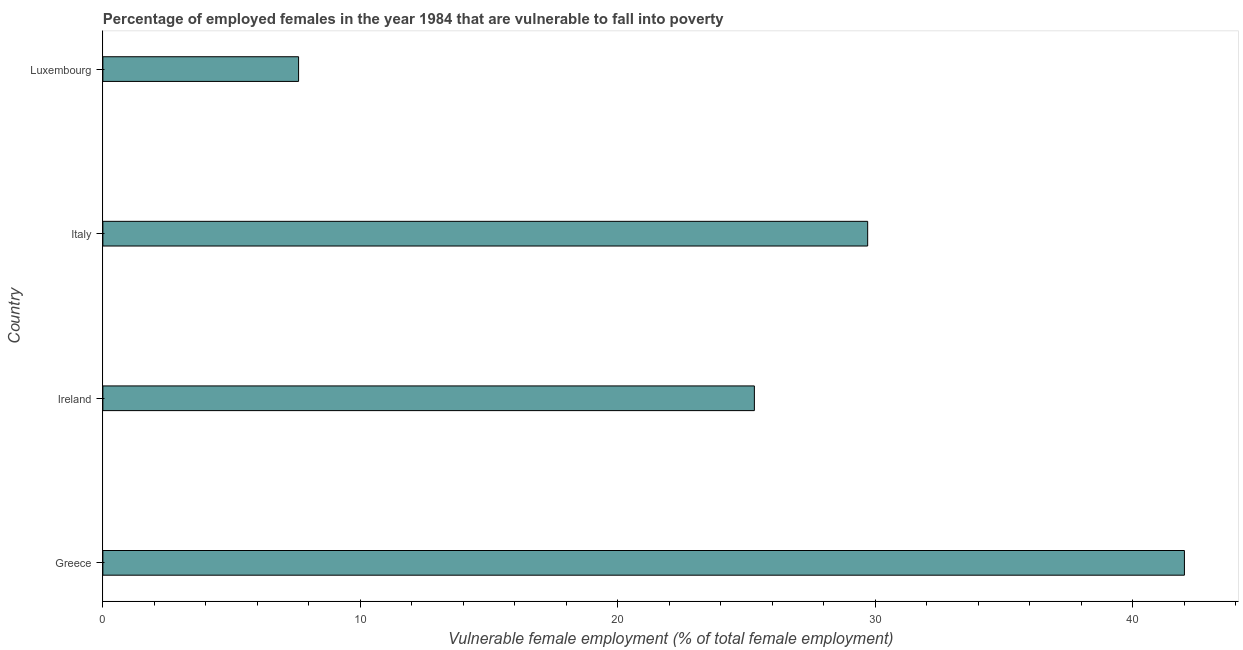Does the graph contain any zero values?
Make the answer very short. No. What is the title of the graph?
Your response must be concise. Percentage of employed females in the year 1984 that are vulnerable to fall into poverty. What is the label or title of the X-axis?
Your response must be concise. Vulnerable female employment (% of total female employment). What is the percentage of employed females who are vulnerable to fall into poverty in Luxembourg?
Your answer should be compact. 7.6. Across all countries, what is the minimum percentage of employed females who are vulnerable to fall into poverty?
Offer a very short reply. 7.6. In which country was the percentage of employed females who are vulnerable to fall into poverty minimum?
Your response must be concise. Luxembourg. What is the sum of the percentage of employed females who are vulnerable to fall into poverty?
Offer a terse response. 104.6. What is the average percentage of employed females who are vulnerable to fall into poverty per country?
Your answer should be very brief. 26.15. What is the ratio of the percentage of employed females who are vulnerable to fall into poverty in Greece to that in Luxembourg?
Offer a very short reply. 5.53. What is the difference between the highest and the lowest percentage of employed females who are vulnerable to fall into poverty?
Keep it short and to the point. 34.4. How many countries are there in the graph?
Provide a short and direct response. 4. Are the values on the major ticks of X-axis written in scientific E-notation?
Ensure brevity in your answer.  No. What is the Vulnerable female employment (% of total female employment) of Greece?
Keep it short and to the point. 42. What is the Vulnerable female employment (% of total female employment) in Ireland?
Provide a succinct answer. 25.3. What is the Vulnerable female employment (% of total female employment) in Italy?
Your answer should be compact. 29.7. What is the Vulnerable female employment (% of total female employment) in Luxembourg?
Offer a terse response. 7.6. What is the difference between the Vulnerable female employment (% of total female employment) in Greece and Ireland?
Ensure brevity in your answer.  16.7. What is the difference between the Vulnerable female employment (% of total female employment) in Greece and Luxembourg?
Your answer should be very brief. 34.4. What is the difference between the Vulnerable female employment (% of total female employment) in Italy and Luxembourg?
Your answer should be compact. 22.1. What is the ratio of the Vulnerable female employment (% of total female employment) in Greece to that in Ireland?
Your response must be concise. 1.66. What is the ratio of the Vulnerable female employment (% of total female employment) in Greece to that in Italy?
Give a very brief answer. 1.41. What is the ratio of the Vulnerable female employment (% of total female employment) in Greece to that in Luxembourg?
Offer a very short reply. 5.53. What is the ratio of the Vulnerable female employment (% of total female employment) in Ireland to that in Italy?
Keep it short and to the point. 0.85. What is the ratio of the Vulnerable female employment (% of total female employment) in Ireland to that in Luxembourg?
Ensure brevity in your answer.  3.33. What is the ratio of the Vulnerable female employment (% of total female employment) in Italy to that in Luxembourg?
Ensure brevity in your answer.  3.91. 